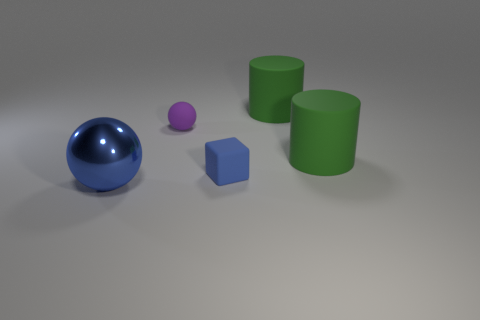Subtract 0 yellow cubes. How many objects are left? 5 Subtract all cubes. How many objects are left? 4 Subtract 1 cubes. How many cubes are left? 0 Subtract all red spheres. Subtract all blue blocks. How many spheres are left? 2 Subtract all brown blocks. How many yellow spheres are left? 0 Subtract all small balls. Subtract all tiny blue rubber cubes. How many objects are left? 3 Add 2 tiny purple rubber spheres. How many tiny purple rubber spheres are left? 3 Add 4 big metal balls. How many big metal balls exist? 5 Add 3 blue metallic balls. How many objects exist? 8 Subtract all blue balls. How many balls are left? 1 